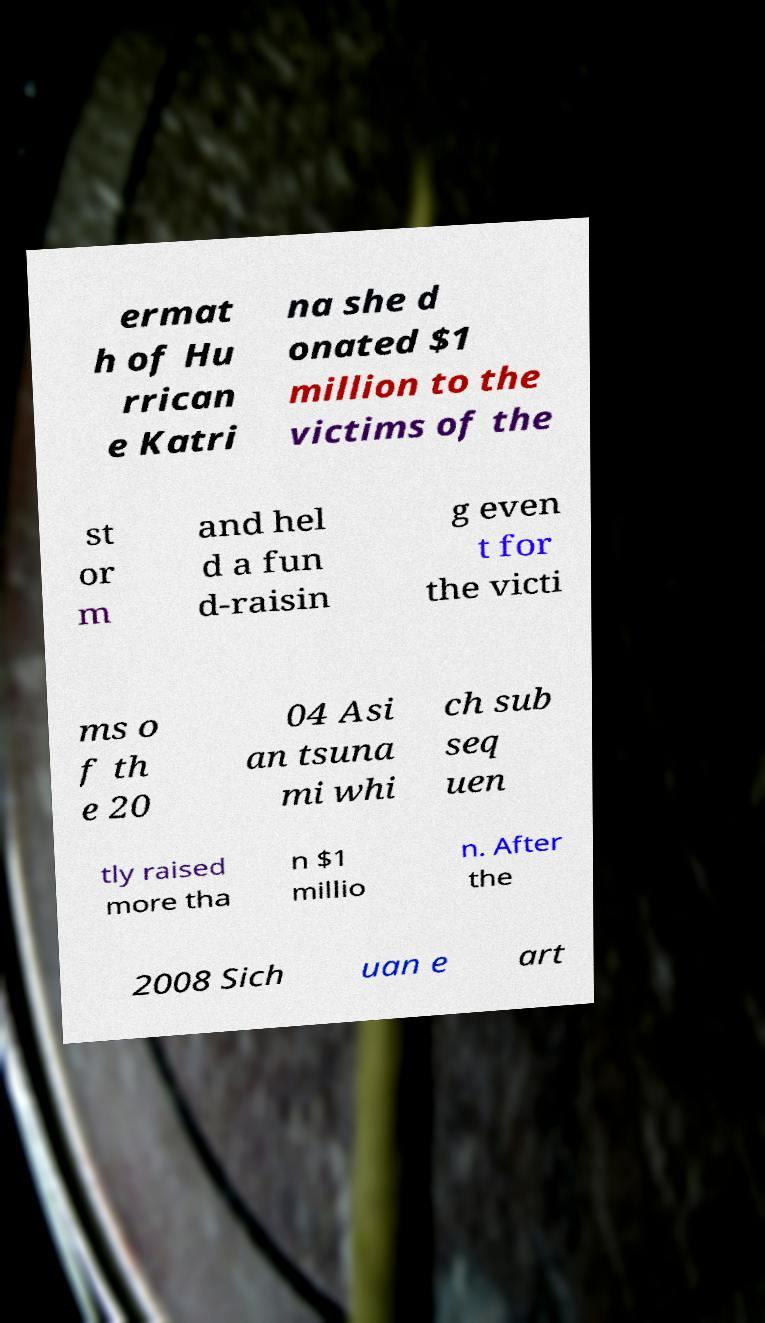Could you assist in decoding the text presented in this image and type it out clearly? ermat h of Hu rrican e Katri na she d onated $1 million to the victims of the st or m and hel d a fun d-raisin g even t for the victi ms o f th e 20 04 Asi an tsuna mi whi ch sub seq uen tly raised more tha n $1 millio n. After the 2008 Sich uan e art 